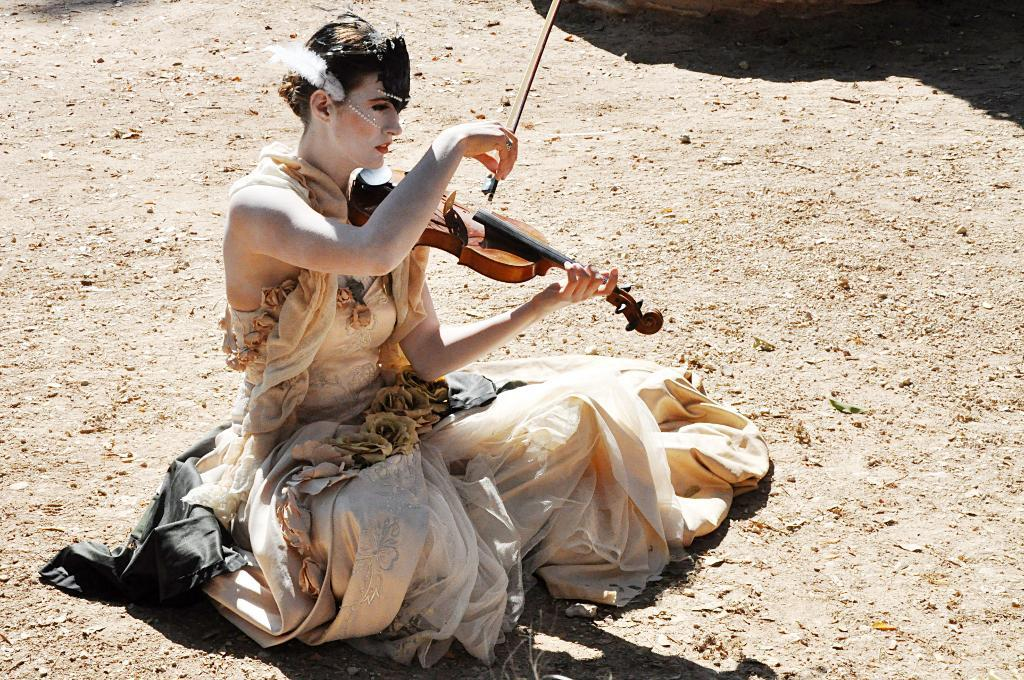Who is the main subject in the image? There is a lady in the image. What is the lady doing in the image? The lady is playing a violin. What type of surface is visible at the bottom of the image? There is ground visible at the bottom of the image. What color are the trousers worn by the lady in the image? There is no information about the lady's trousers in the image, so we cannot determine their color. How many rails can be seen in the image? There are no rails present in the image. 